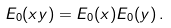<formula> <loc_0><loc_0><loc_500><loc_500>E _ { 0 } ( x y ) = E _ { 0 } ( x ) E _ { 0 } ( y ) \, .</formula> 